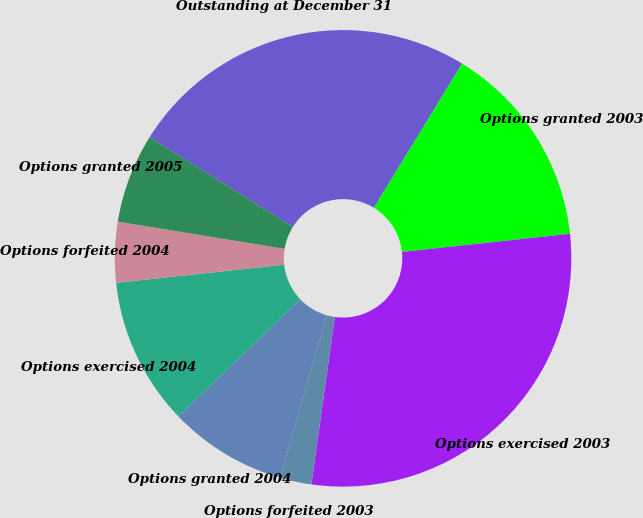Convert chart. <chart><loc_0><loc_0><loc_500><loc_500><pie_chart><fcel>Outstanding at December 31<fcel>Options granted 2003<fcel>Options exercised 2003<fcel>Options forfeited 2003<fcel>Options granted 2004<fcel>Options exercised 2004<fcel>Options forfeited 2004<fcel>Options granted 2005<nl><fcel>24.82%<fcel>14.55%<fcel>28.93%<fcel>2.23%<fcel>8.39%<fcel>10.45%<fcel>4.28%<fcel>6.34%<nl></chart> 